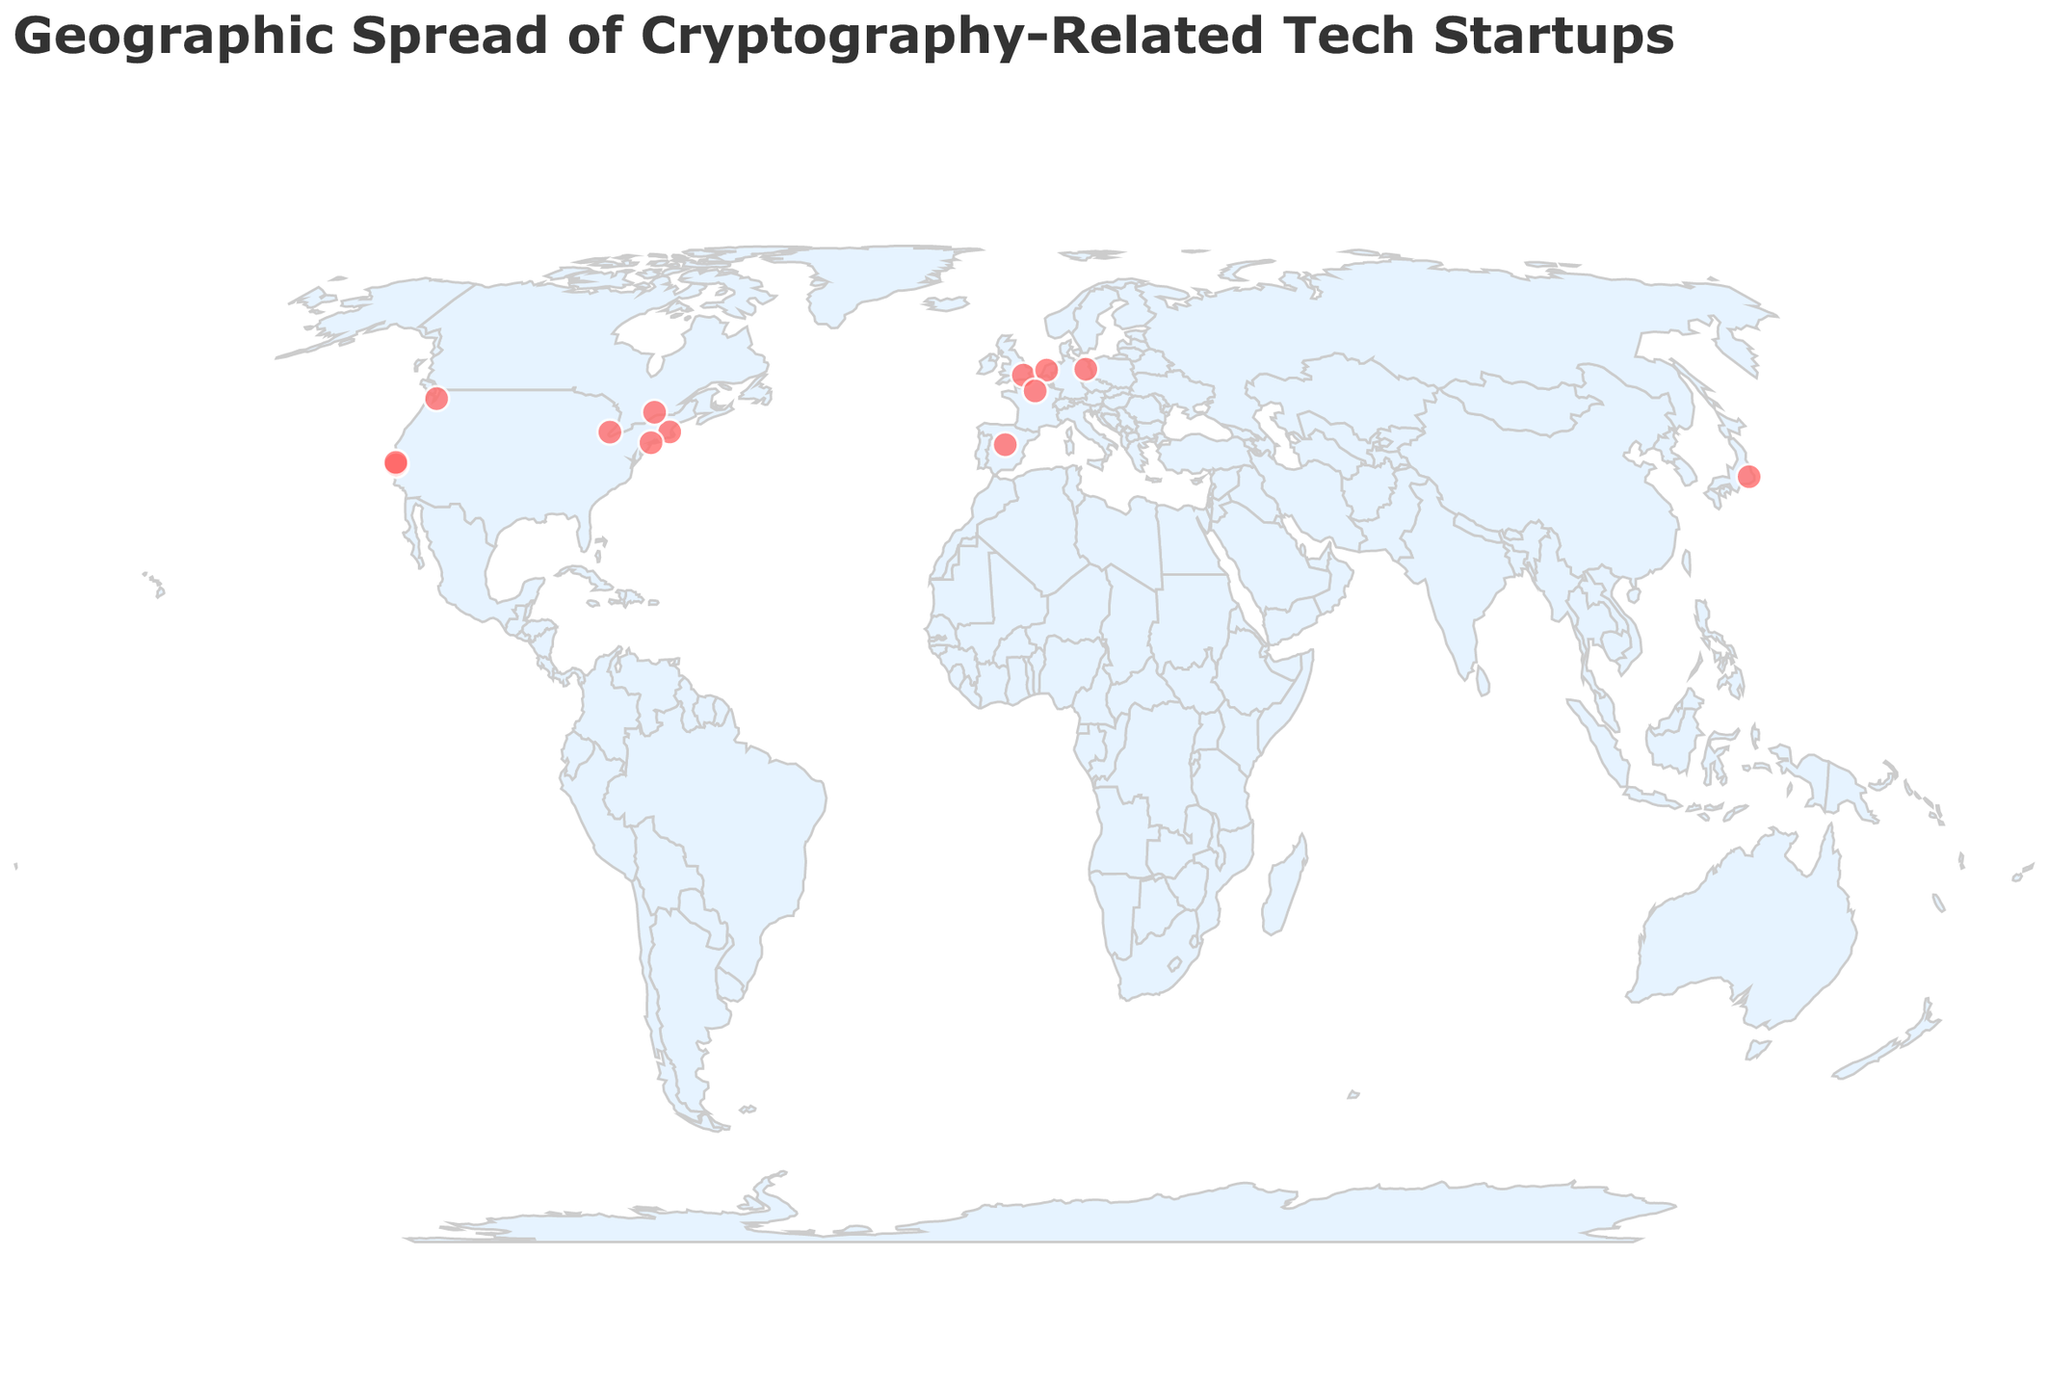What is the general title of the figure? The title of the figure is displayed at the top and it indicates what the figure is about. Reading it helps in understanding the context.
Answer: Geographic Spread of Cryptography-Related Tech Startups Which company is based in Tokyo and what is its focus? Look for the data point located at the coordinates corresponding to Tokyo (35.6762, 139.6503). The tooltip will display the company's name and its focus.
Answer: Keychain, Distributed Key Management How many companies are located in the United States? Identify the data points located in the United States by observing data points within known US geographical coordinates. Count them.
Answer: 6 Which company focuses on Hardware Wallets and where is it located? Look for the data point with "Hardware Wallets" listed as the focus in the tooltip. Then check the geographical coordinates provided for its location.
Answer: Ledger, Paris Are there any companies with the same focus located in the same city? Look for overlapping data points (same coordinates) and compare their focus fields from the tooltips.
Answer: No Compare the number of companies focusing on Blockchain Security to those on Post-Quantum Cryptography. Which is higher? Identify and count companies with "Blockchain Security" and "Post-Quantum Cryptography" as their focus from the tooltips. Compare the two counts.
Answer: Blockchain Security is higher What is the focus of the company located in Amsterdam? Locate the data point corresponding to Amsterdam (52.3676, 4.9041) and check the tooltip for its focus.
Answer: Blockchain Cryptography Which city has the highest concentration of cryptography-related tech startups? Observe the map for overlapping or closely positioned data points and check the corresponding city in the tooltips.
Answer: San Francisco What is the average latitude of companies focusing on encryption technologies (Homomorphic, Hardware-based, Searchable)? Identify companies with the mentioned focuses and note their latitudes. Calculate their average latitude. Explanation: - NuCypher (37.7749) - Fortanix (37.3861) - StrongSalt (42.3314) (37.7749 + 37.3861 + 42.3314) / 3 = 39.164133
Answer: 39.1641 How many companies are focusing on Blockchain-related technologies? Identify companies with any variation of "Blockchain" in their focus and count them.
Answer: 3 